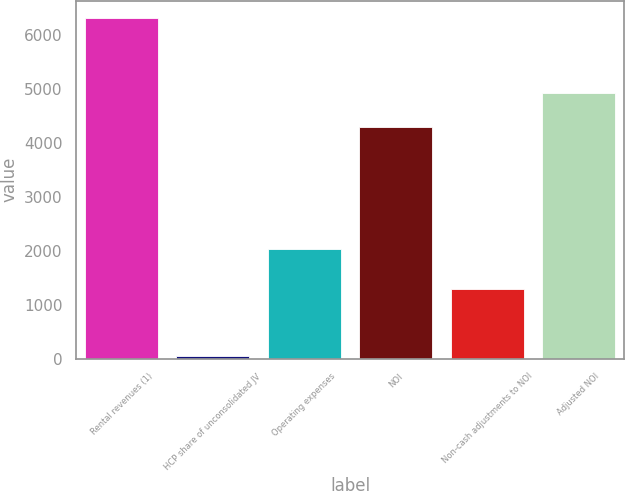<chart> <loc_0><loc_0><loc_500><loc_500><bar_chart><fcel>Rental revenues (1)<fcel>HCP share of unconsolidated JV<fcel>Operating expenses<fcel>NOI<fcel>Non-cash adjustments to NOI<fcel>Adjusted NOI<nl><fcel>6327<fcel>41<fcel>2036<fcel>4295<fcel>1298.2<fcel>4923.6<nl></chart> 